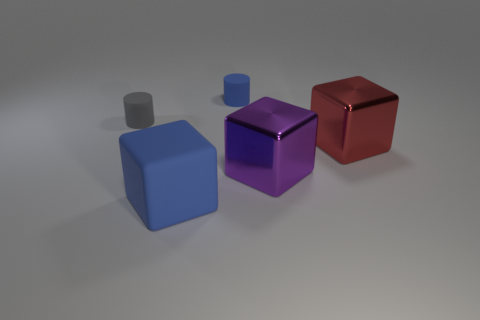Add 5 big red cylinders. How many objects exist? 10 Subtract all cylinders. How many objects are left? 3 Subtract 0 blue spheres. How many objects are left? 5 Subtract all red metallic things. Subtract all yellow shiny balls. How many objects are left? 4 Add 5 tiny gray matte cylinders. How many tiny gray matte cylinders are left? 6 Add 4 big purple objects. How many big purple objects exist? 5 